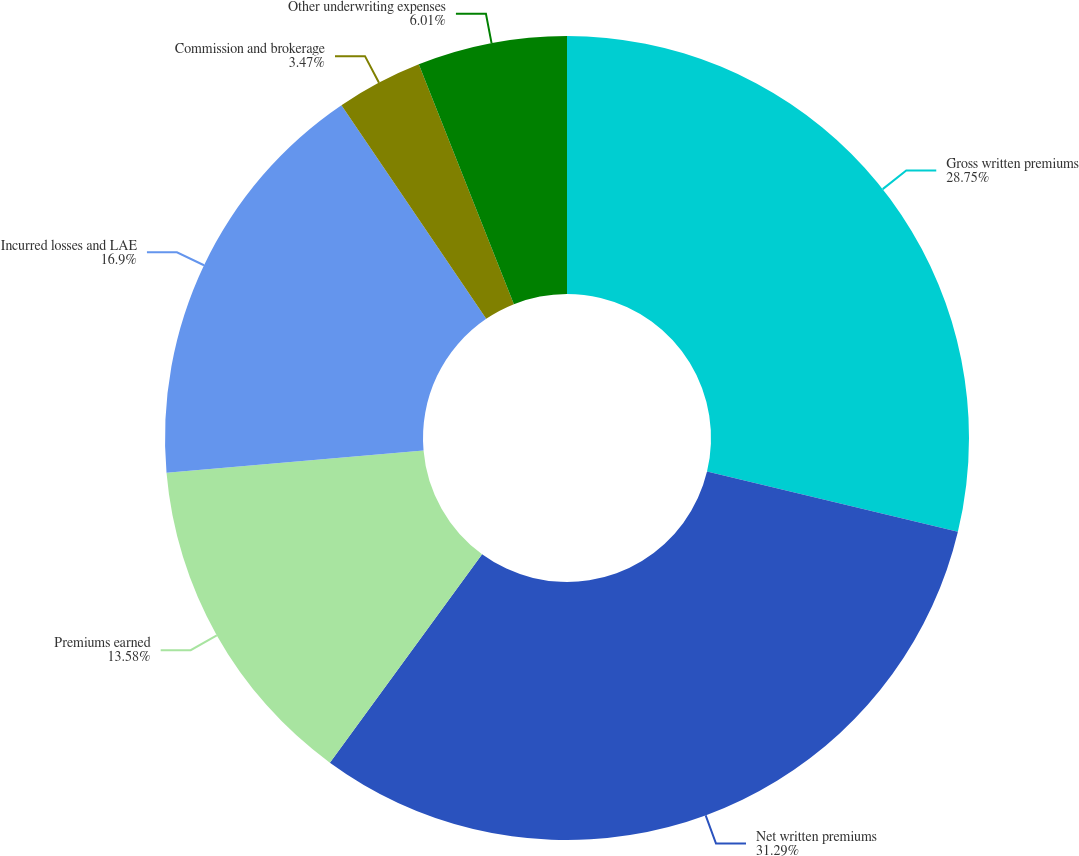<chart> <loc_0><loc_0><loc_500><loc_500><pie_chart><fcel>Gross written premiums<fcel>Net written premiums<fcel>Premiums earned<fcel>Incurred losses and LAE<fcel>Commission and brokerage<fcel>Other underwriting expenses<nl><fcel>28.75%<fcel>31.29%<fcel>13.58%<fcel>16.9%<fcel>3.47%<fcel>6.01%<nl></chart> 